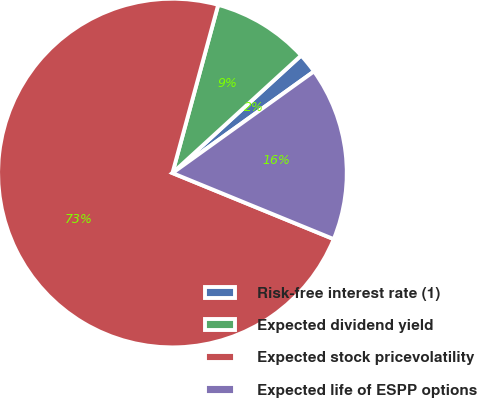Convert chart to OTSL. <chart><loc_0><loc_0><loc_500><loc_500><pie_chart><fcel>Risk-free interest rate (1)<fcel>Expected dividend yield<fcel>Expected stock pricevolatility<fcel>Expected life of ESPP options<nl><fcel>1.87%<fcel>8.99%<fcel>73.03%<fcel>16.1%<nl></chart> 